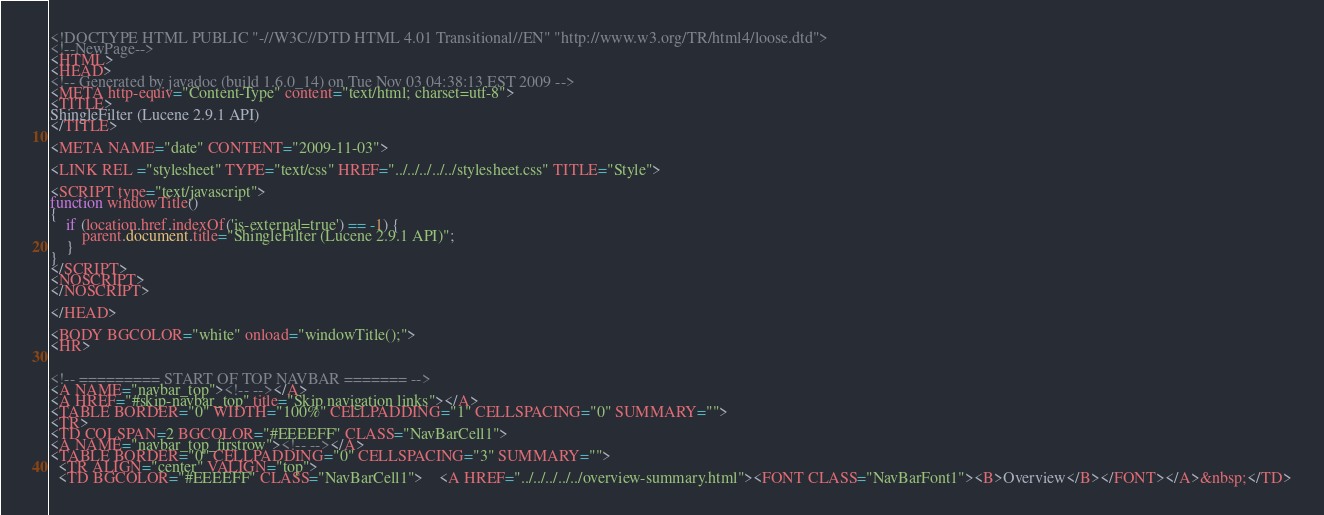<code> <loc_0><loc_0><loc_500><loc_500><_HTML_><!DOCTYPE HTML PUBLIC "-//W3C//DTD HTML 4.01 Transitional//EN" "http://www.w3.org/TR/html4/loose.dtd">
<!--NewPage-->
<HTML>
<HEAD>
<!-- Generated by javadoc (build 1.6.0_14) on Tue Nov 03 04:38:13 EST 2009 -->
<META http-equiv="Content-Type" content="text/html; charset=utf-8">
<TITLE>
ShingleFilter (Lucene 2.9.1 API)
</TITLE>

<META NAME="date" CONTENT="2009-11-03">

<LINK REL ="stylesheet" TYPE="text/css" HREF="../../../../../stylesheet.css" TITLE="Style">

<SCRIPT type="text/javascript">
function windowTitle()
{
    if (location.href.indexOf('is-external=true') == -1) {
        parent.document.title="ShingleFilter (Lucene 2.9.1 API)";
    }
}
</SCRIPT>
<NOSCRIPT>
</NOSCRIPT>

</HEAD>

<BODY BGCOLOR="white" onload="windowTitle();">
<HR>


<!-- ========= START OF TOP NAVBAR ======= -->
<A NAME="navbar_top"><!-- --></A>
<A HREF="#skip-navbar_top" title="Skip navigation links"></A>
<TABLE BORDER="0" WIDTH="100%" CELLPADDING="1" CELLSPACING="0" SUMMARY="">
<TR>
<TD COLSPAN=2 BGCOLOR="#EEEEFF" CLASS="NavBarCell1">
<A NAME="navbar_top_firstrow"><!-- --></A>
<TABLE BORDER="0" CELLPADDING="0" CELLSPACING="3" SUMMARY="">
  <TR ALIGN="center" VALIGN="top">
  <TD BGCOLOR="#EEEEFF" CLASS="NavBarCell1">    <A HREF="../../../../../overview-summary.html"><FONT CLASS="NavBarFont1"><B>Overview</B></FONT></A>&nbsp;</TD></code> 